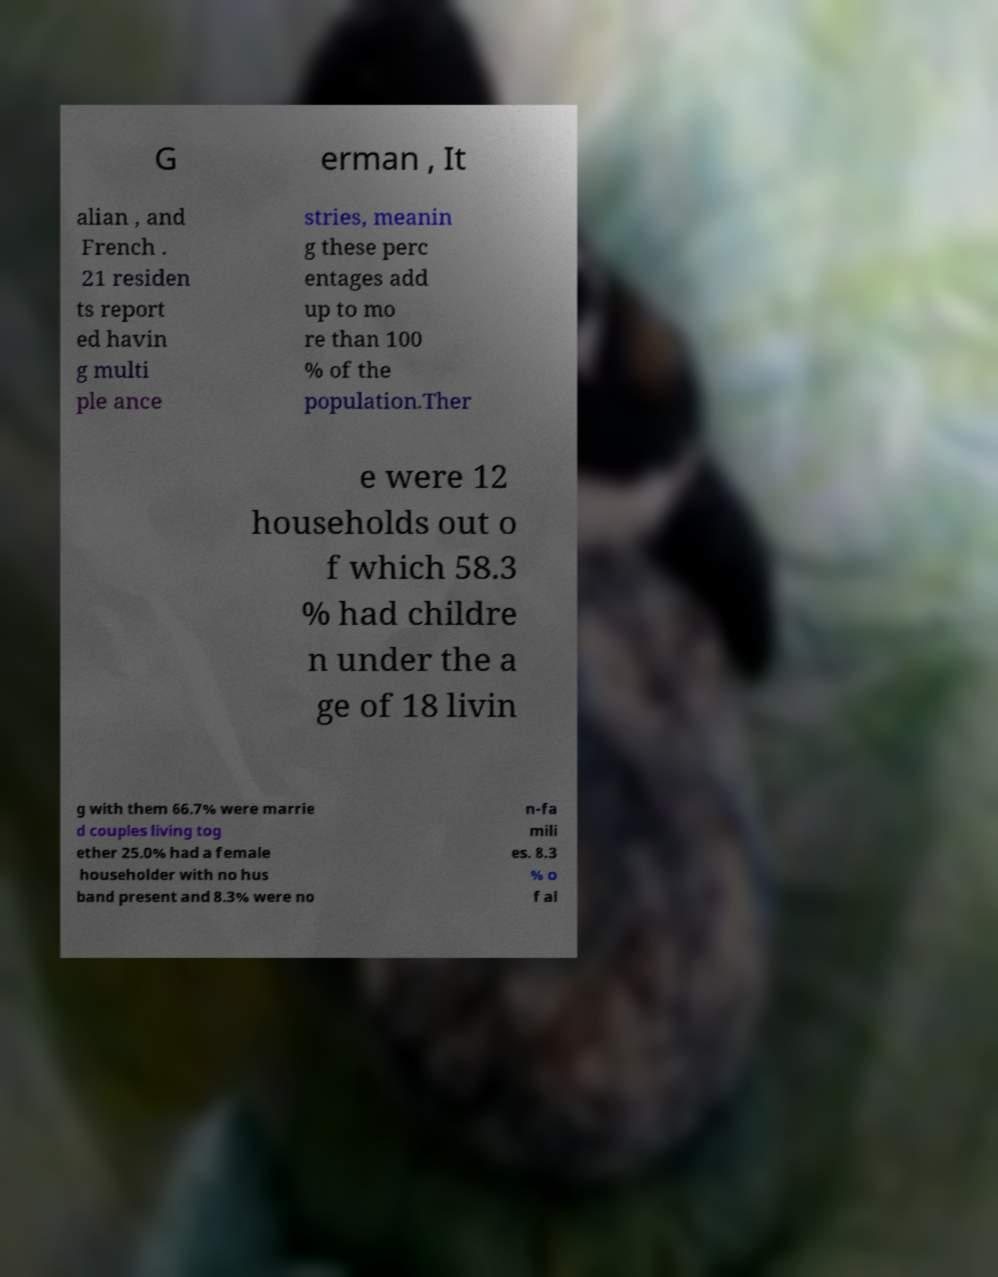Can you read and provide the text displayed in the image?This photo seems to have some interesting text. Can you extract and type it out for me? G erman , It alian , and French . 21 residen ts report ed havin g multi ple ance stries, meanin g these perc entages add up to mo re than 100 % of the population.Ther e were 12 households out o f which 58.3 % had childre n under the a ge of 18 livin g with them 66.7% were marrie d couples living tog ether 25.0% had a female householder with no hus band present and 8.3% were no n-fa mili es. 8.3 % o f al 